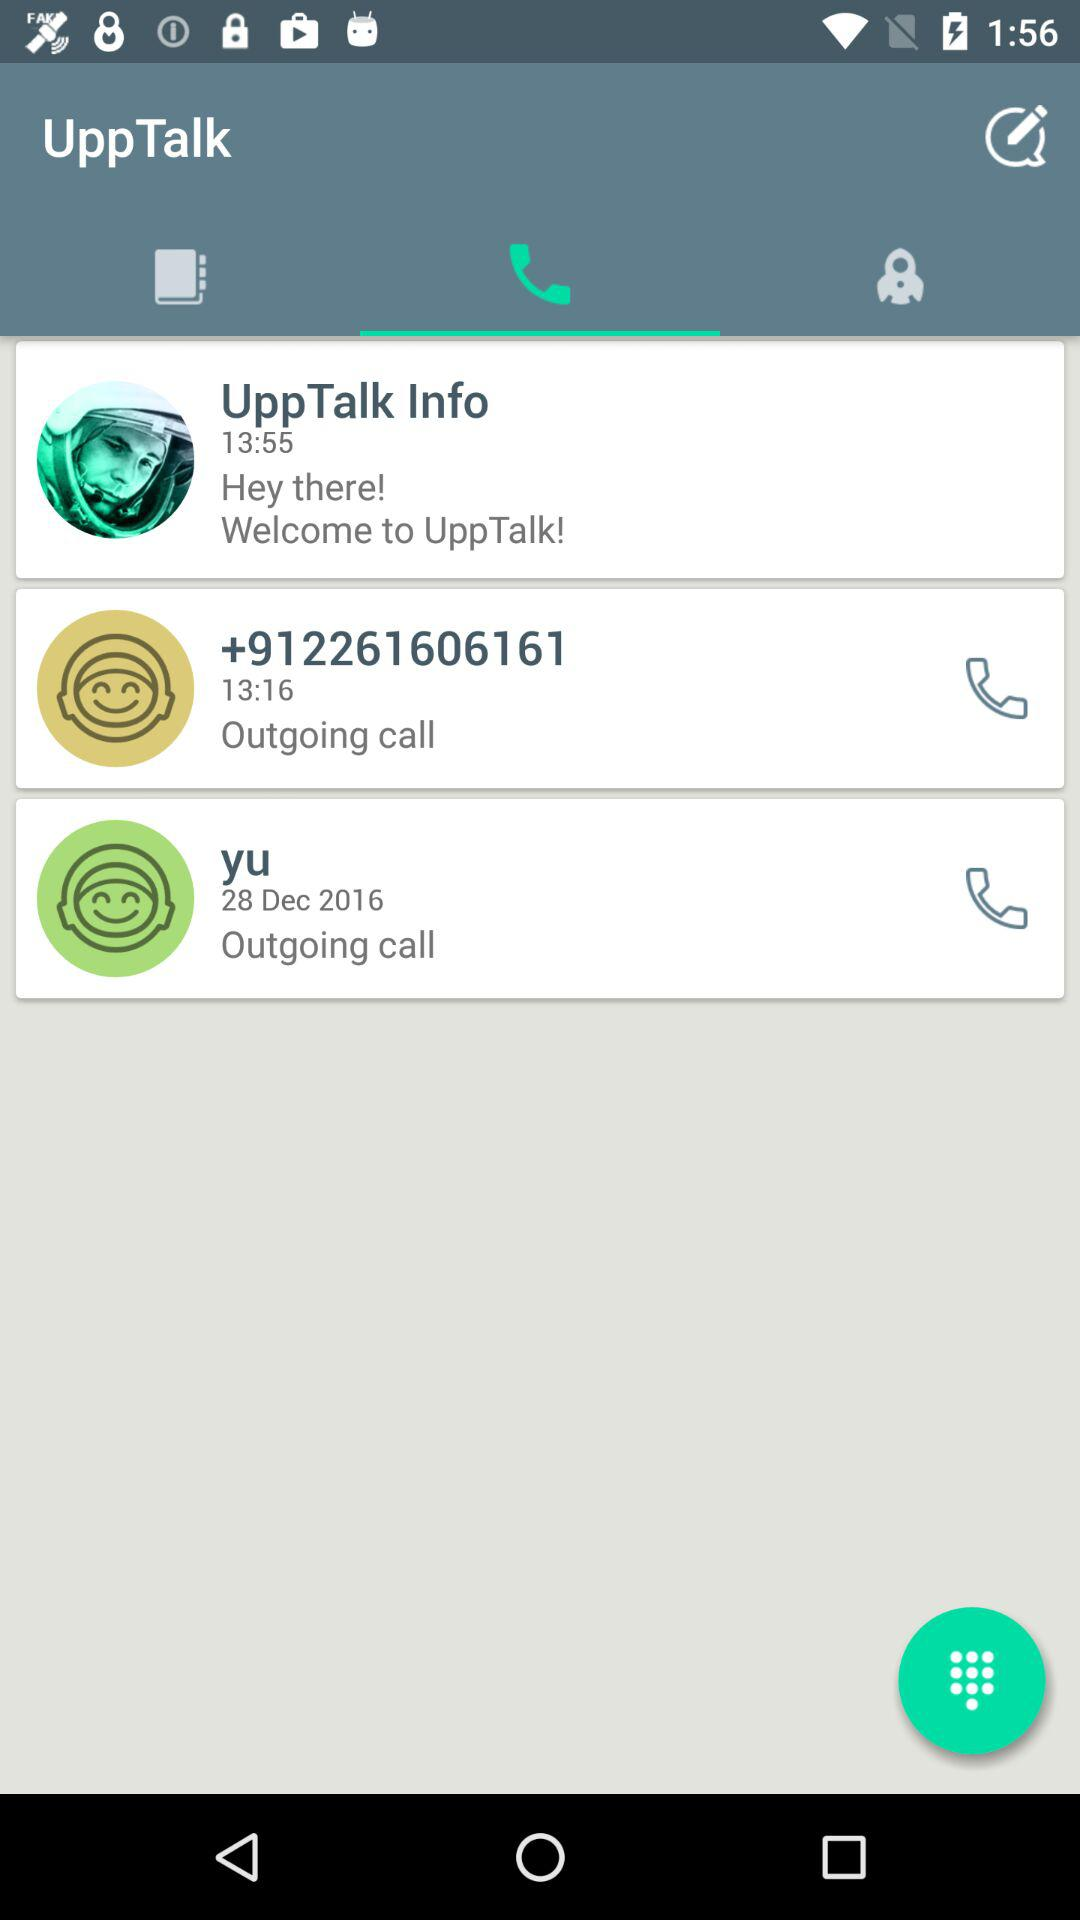What is the time of the outgoing call with the number +912261606161? The time of the outgoing call is 13:16. 